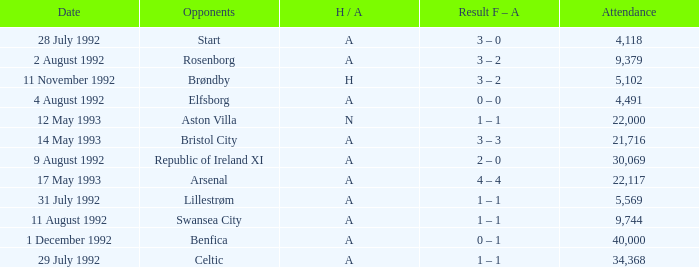Which Result F-A has Opponents of rosenborg? 3 – 2. 